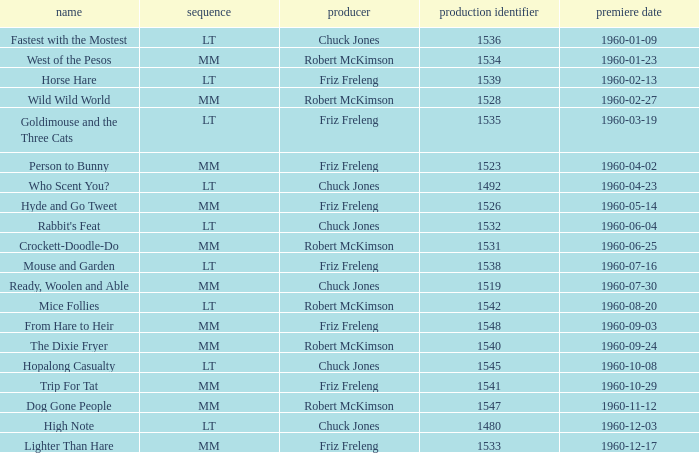Write the full table. {'header': ['name', 'sequence', 'producer', 'production identifier', 'premiere date'], 'rows': [['Fastest with the Mostest', 'LT', 'Chuck Jones', '1536', '1960-01-09'], ['West of the Pesos', 'MM', 'Robert McKimson', '1534', '1960-01-23'], ['Horse Hare', 'LT', 'Friz Freleng', '1539', '1960-02-13'], ['Wild Wild World', 'MM', 'Robert McKimson', '1528', '1960-02-27'], ['Goldimouse and the Three Cats', 'LT', 'Friz Freleng', '1535', '1960-03-19'], ['Person to Bunny', 'MM', 'Friz Freleng', '1523', '1960-04-02'], ['Who Scent You?', 'LT', 'Chuck Jones', '1492', '1960-04-23'], ['Hyde and Go Tweet', 'MM', 'Friz Freleng', '1526', '1960-05-14'], ["Rabbit's Feat", 'LT', 'Chuck Jones', '1532', '1960-06-04'], ['Crockett-Doodle-Do', 'MM', 'Robert McKimson', '1531', '1960-06-25'], ['Mouse and Garden', 'LT', 'Friz Freleng', '1538', '1960-07-16'], ['Ready, Woolen and Able', 'MM', 'Chuck Jones', '1519', '1960-07-30'], ['Mice Follies', 'LT', 'Robert McKimson', '1542', '1960-08-20'], ['From Hare to Heir', 'MM', 'Friz Freleng', '1548', '1960-09-03'], ['The Dixie Fryer', 'MM', 'Robert McKimson', '1540', '1960-09-24'], ['Hopalong Casualty', 'LT', 'Chuck Jones', '1545', '1960-10-08'], ['Trip For Tat', 'MM', 'Friz Freleng', '1541', '1960-10-29'], ['Dog Gone People', 'MM', 'Robert McKimson', '1547', '1960-11-12'], ['High Note', 'LT', 'Chuck Jones', '1480', '1960-12-03'], ['Lighter Than Hare', 'MM', 'Friz Freleng', '1533', '1960-12-17']]} What is the Series number of the episode with a production number of 1547? MM. 